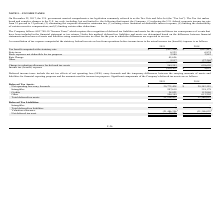According to Telkonet's financial document, Which guide does the Company follow to determine their deferred tax liabilities and assets? ASC 740-10 “Income Taxes”. The document states: "ting certain other deductions. The Company follows ASC 740-10 “Income Taxes” which requires the recognition of deferred tax liabilities and assets for..." Also, What is the income tax benefit in 2019? According to the financial document, 100,363. The relevant text states: "Income tax (benefit) expense $ (100,363 ) $ 9,623..." Also, What is the change in valuation allowance for deferred tax assets in 2018? According to the financial document, 658,650. The relevant text states: "luation allowance for deferred tax assets 269,203 658,650..." Also, can you calculate: What is the change in state taxes from 2018 to 2019? Based on the calculation: 6,525-6,874, the result is -349. This is based on the information: "State taxes 6,525 6,874 State taxes 6,525 6,874..." The key data points involved are: 6,525, 6,874. Also, can you calculate: What is the percentage change in Book expenses not deductible for tax purposes from 2018 to 2019? To answer this question, I need to perform calculations using the financial data. The calculation is: (2,980-2,882)/2,882, which equals 3.4 (percentage). This is based on the information: "Book expenses not deductible for tax purposes 2,980 2,882 ok expenses not deductible for tax purposes 2,980 2,882..." The key data points involved are: 2,882, 2,980. Also, can you calculate: What is the percentage change in the Tax benefit computed at the statutory rate from 2018 to 2019? To answer this question, I need to perform calculations using the financial data. The calculation is: (427,244-631,497)/631,497, which equals -32.34 (percentage). This is based on the information: "Tax benefit computed at the statutory rate $ (427,244) $ (631,497) fit computed at the statutory rate $ (427,244) $ (631,497)..." The key data points involved are: 427,244, 631,497. 